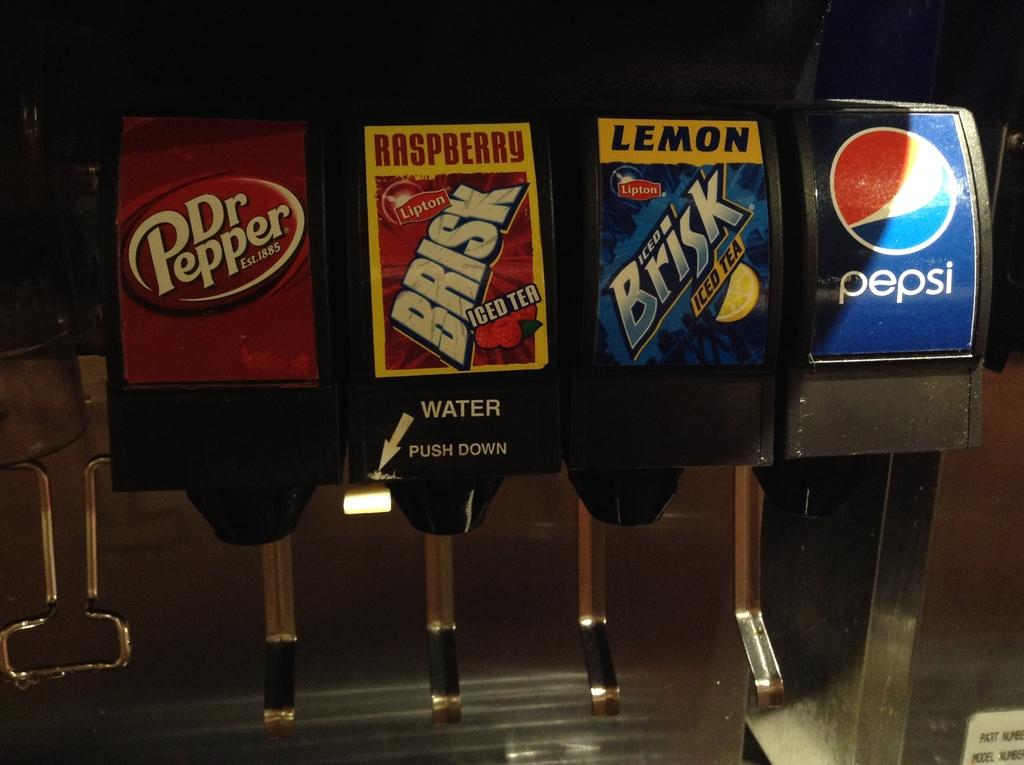What is the main object in the image? There is a soda machine in the image. Can you describe any specific features of the soda machine? There is text or writing on the soda machine. What type of wood is used to make the wine barrels in the image? There are no wine barrels or wood present in the image; it features a soda machine with text or writing on it. 